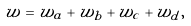<formula> <loc_0><loc_0><loc_500><loc_500>w = w _ { a } + w _ { b } + w _ { c } + w _ { d } ,</formula> 